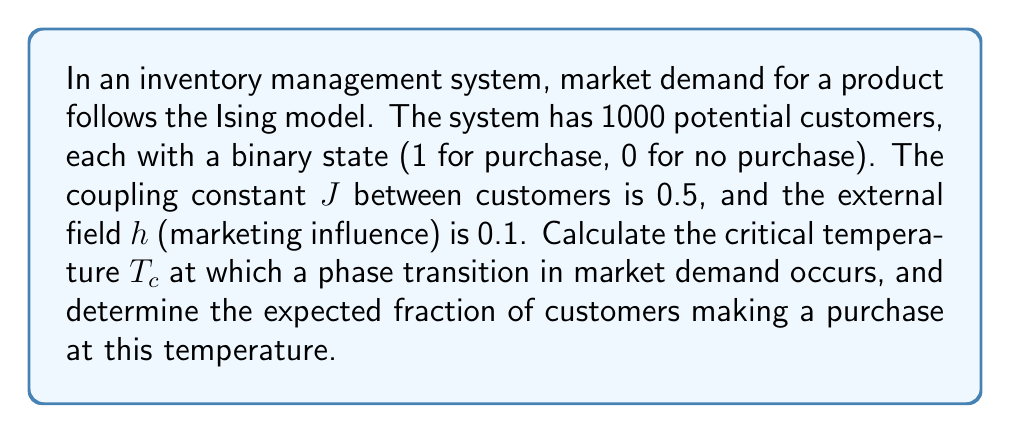Solve this math problem. 1. The critical temperature $T_c$ for the Ising model in mean-field theory is given by:

   $$T_c = \frac{zJ}{k_B}$$

   where $z$ is the number of nearest neighbors, $J$ is the coupling constant, and $k_B$ is the Boltzmann constant.

2. In a fully connected network (which we assume for this market model), $z = N - 1$, where $N$ is the total number of customers. So:

   $$T_c = \frac{(1000 - 1) \cdot 0.5}{k_B} = \frac{499.5}{k_B}$$

3. At the critical temperature, the magnetization $m$ (which represents the fraction of customers making a purchase) follows the equation:

   $$m = \tanh\left(\frac{zJm + h}{k_BT_c}\right)$$

4. Substituting the values:

   $$m = \tanh\left(\frac{999 \cdot 0.5m + 0.1}{499.5} \cdot 499.5\right) = \tanh(m + 0.1)$$

5. This transcendental equation can be solved numerically. The solution is approximately:

   $$m \approx 0.3152$$

Therefore, at the critical temperature, about 31.52% of customers are expected to make a purchase.
Answer: $T_c = 499.5/k_B$; 31.52% of customers purchase 